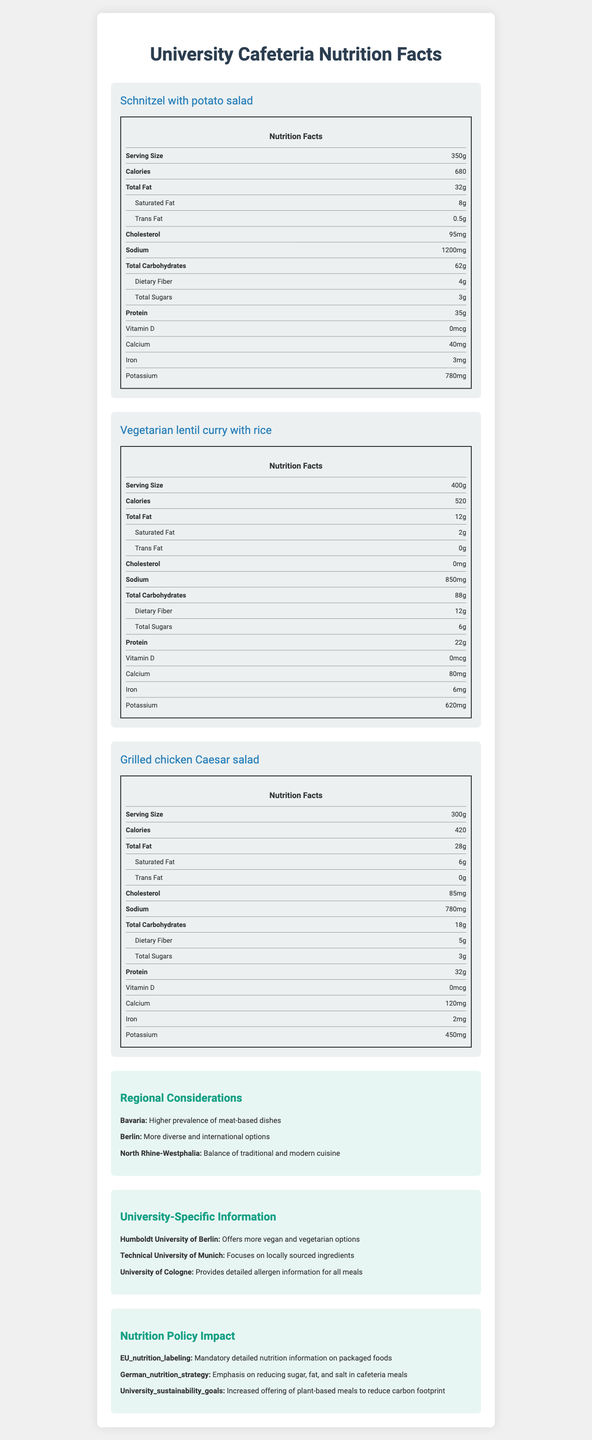what is the serving size for the Schnitzel with potato salad? The serving size for the Schnitzel with potato salad is listed directly under its name in the nutrition facts.
Answer: 350g how many calories are in the Grilled chicken Caesar salad? The calorie count for the Grilled chicken Caesar salad is shown as 420 in the nutrition label for that meal.
Answer: 420 how much protein does the Vegetarian lentil curry with rice contain? The protein content for the Vegetarian lentil curry with rice is listed as 22 grams in the nutrition facts for that meal.
Answer: 22g what is the amount of dietary fiber in the Schnitzel with potato salad? The dietary fiber content for the Schnitzel with potato salad is 4 grams as shown in its nutrition facts.
Answer: 4g what are the regional considerations for Bavaria? The document states that Bavaria has a higher prevalence of meat-based dishes under the Regional Considerations section.
Answer: Higher prevalence of meat-based dishes which meal contains the most total fat? 
A. Schnitzel with potato salad 
B. Vegetarian lentil curry with rice 
C. Grilled chicken Caesar salad The Schnitzel with potato salad contains the most total fat at 32 grams.
Answer: A what is the calcium content in the Grilled chicken Caesar salad? 
A. 80mg 
B. 120mg 
C. 40mg 
D. 95mg The calcium content in the Grilled chicken Caesar salad is listed as 120mg in its nutrition facts.
Answer: B is there any trans fat in the Vegetarian lentil curry with rice? The document shows that the Vegetarian lentil curry with rice contains 0 grams of trans fat.
Answer: No summarize the main idea of the document. The document offers a comprehensive overview of the nutritional content of specific cafeteria meals, considerations for different regions in Germany, specific university practices, and the influence of nutrition policies.
Answer: The document provides detailed nutrition facts for three typical university cafeteria meals, including the Schnitzel with potato salad, Vegetarian lentil curry with rice, and Grilled chicken Caesar salad. It also details regional considerations, university-specific information, and the impact of nutrition policies. how much Vitamin D is in the Schnitzel with potato salad? The nutrition facts label for the Schnitzel with potato salad states that it contains 0mcg of Vitamin D.
Answer: 0mcg what type of dishes are more common in Berlin according to the document? The document specifies that Berlin has more diverse and international options under the Regional Considerations section.
Answer: More diverse and international options which university focuses on locally sourced ingredients? 
1. Humboldt University of Berlin 
2. Technical University of Munich 
3. University of Cologne The Technical University of Munich focuses on locally sourced ingredients.
Answer: 2 are the cafeteria meals part of the German nutrition policy? The document does not explicitly state whether the listed cafeteria meals are part of the German nutrition policy.
Answer: Not enough information 